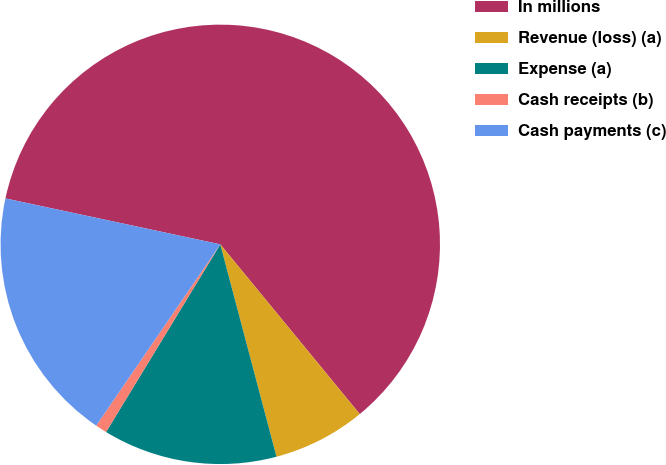Convert chart. <chart><loc_0><loc_0><loc_500><loc_500><pie_chart><fcel>In millions<fcel>Revenue (loss) (a)<fcel>Expense (a)<fcel>Cash receipts (b)<fcel>Cash payments (c)<nl><fcel>60.7%<fcel>6.83%<fcel>12.82%<fcel>0.85%<fcel>18.8%<nl></chart> 